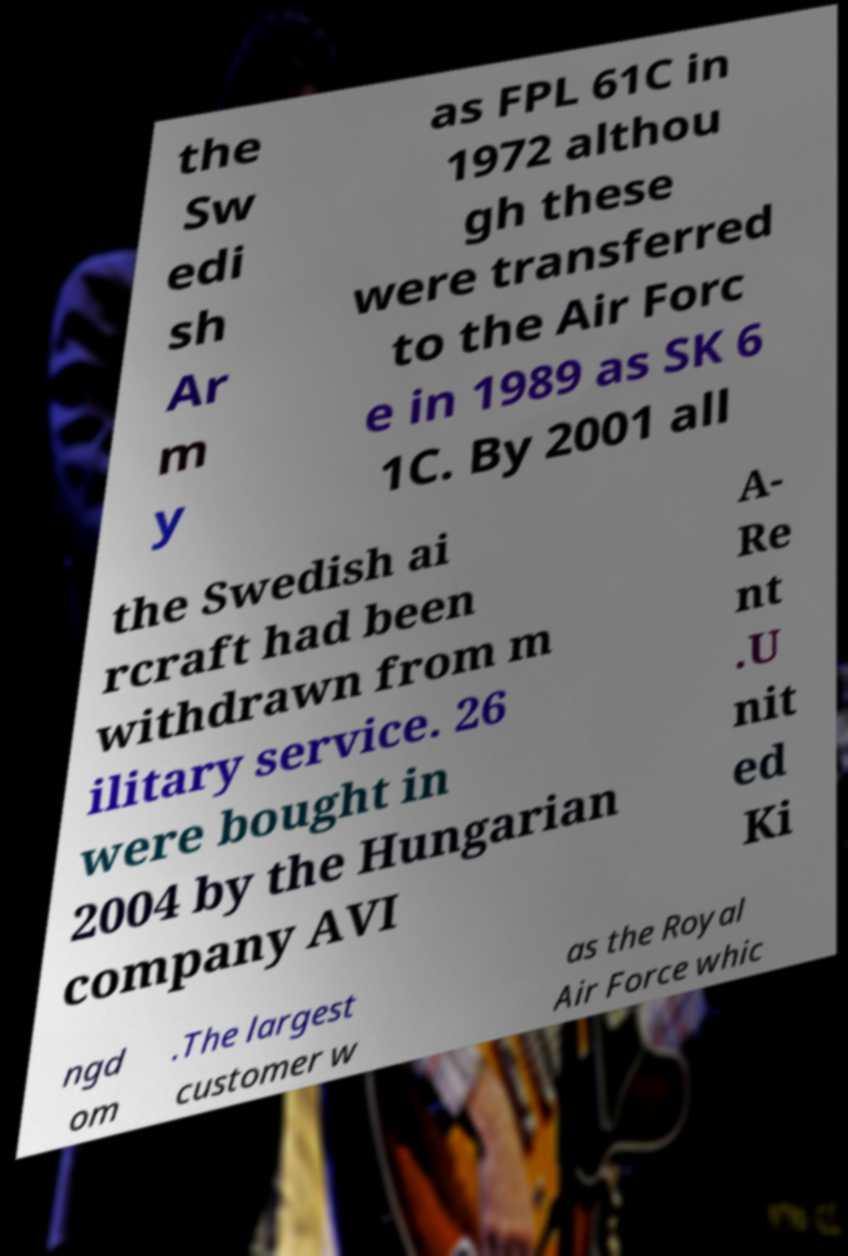There's text embedded in this image that I need extracted. Can you transcribe it verbatim? the Sw edi sh Ar m y as FPL 61C in 1972 althou gh these were transferred to the Air Forc e in 1989 as SK 6 1C. By 2001 all the Swedish ai rcraft had been withdrawn from m ilitary service. 26 were bought in 2004 by the Hungarian company AVI A- Re nt .U nit ed Ki ngd om .The largest customer w as the Royal Air Force whic 